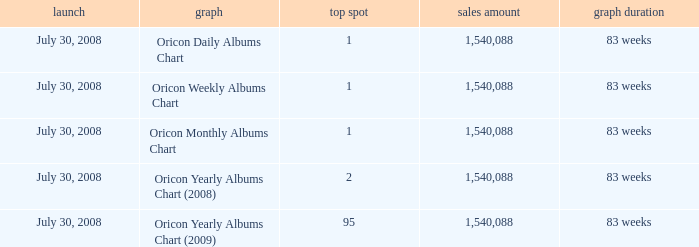How much Peak Position has Sales Total larger than 1,540,088? 0.0. 